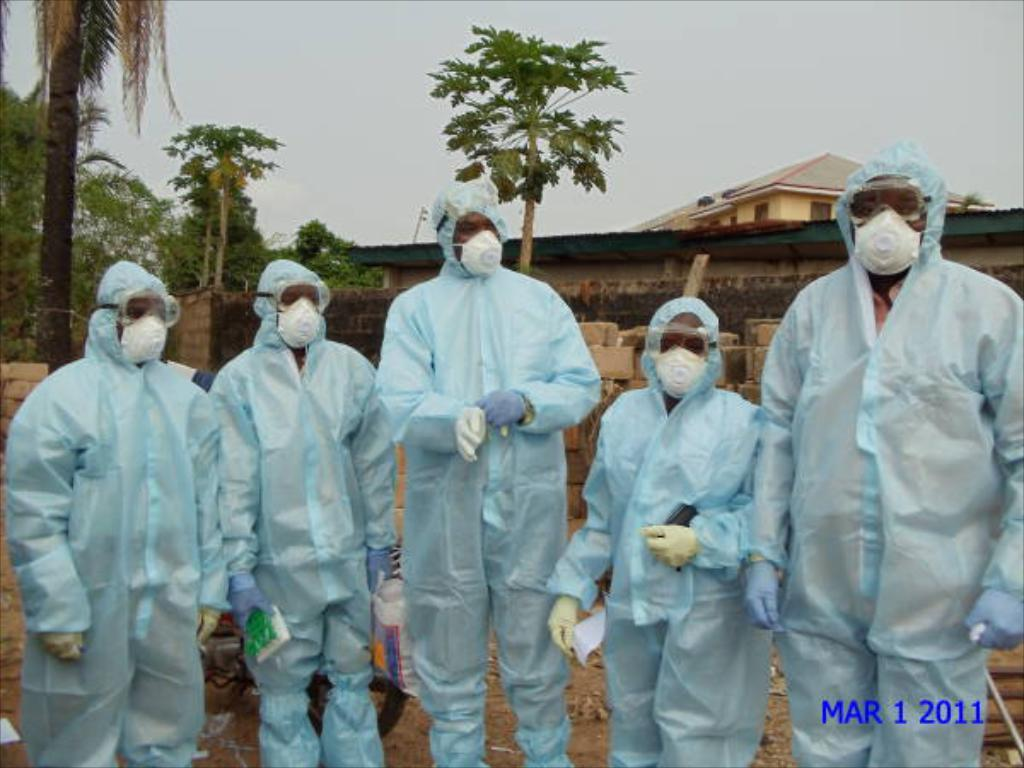Who or what is present in the image? There are people in the image. What are the people wearing on their faces? The people are wearing white color masks. What color are the dresses worn by the people? The people are wearing blue color dresses. What can be seen in the background of the image? There is a house and trees in the background of the image. What is the color of the sky in the image? The sky is white in the image. What type of protest is taking place in the image? There is no protest present in the image; it features people wearing masks and blue dresses, with a house, trees, and a white sky in the background. 